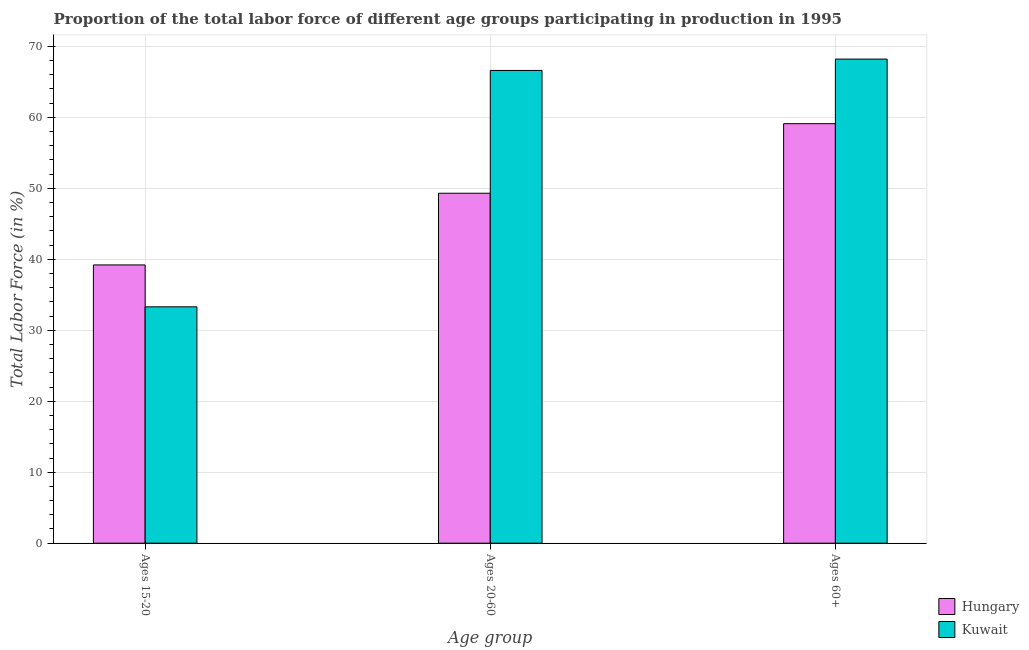How many different coloured bars are there?
Provide a short and direct response. 2. Are the number of bars per tick equal to the number of legend labels?
Ensure brevity in your answer.  Yes. How many bars are there on the 3rd tick from the left?
Ensure brevity in your answer.  2. What is the label of the 2nd group of bars from the left?
Ensure brevity in your answer.  Ages 20-60. What is the percentage of labor force within the age group 15-20 in Kuwait?
Keep it short and to the point. 33.3. Across all countries, what is the maximum percentage of labor force within the age group 20-60?
Make the answer very short. 66.6. Across all countries, what is the minimum percentage of labor force within the age group 15-20?
Provide a succinct answer. 33.3. In which country was the percentage of labor force within the age group 15-20 maximum?
Give a very brief answer. Hungary. In which country was the percentage of labor force within the age group 20-60 minimum?
Your response must be concise. Hungary. What is the total percentage of labor force above age 60 in the graph?
Ensure brevity in your answer.  127.3. What is the difference between the percentage of labor force within the age group 15-20 in Kuwait and that in Hungary?
Your answer should be compact. -5.9. What is the average percentage of labor force within the age group 20-60 per country?
Offer a terse response. 57.95. What is the difference between the percentage of labor force above age 60 and percentage of labor force within the age group 15-20 in Hungary?
Your response must be concise. 19.9. In how many countries, is the percentage of labor force above age 60 greater than 12 %?
Your response must be concise. 2. What is the ratio of the percentage of labor force within the age group 15-20 in Hungary to that in Kuwait?
Your answer should be very brief. 1.18. Is the percentage of labor force within the age group 15-20 in Kuwait less than that in Hungary?
Give a very brief answer. Yes. Is the difference between the percentage of labor force above age 60 in Hungary and Kuwait greater than the difference between the percentage of labor force within the age group 15-20 in Hungary and Kuwait?
Keep it short and to the point. No. What is the difference between the highest and the second highest percentage of labor force within the age group 20-60?
Provide a short and direct response. 17.3. What is the difference between the highest and the lowest percentage of labor force within the age group 20-60?
Provide a succinct answer. 17.3. In how many countries, is the percentage of labor force within the age group 15-20 greater than the average percentage of labor force within the age group 15-20 taken over all countries?
Ensure brevity in your answer.  1. Is the sum of the percentage of labor force within the age group 15-20 in Hungary and Kuwait greater than the maximum percentage of labor force above age 60 across all countries?
Ensure brevity in your answer.  Yes. What does the 2nd bar from the left in Ages 60+ represents?
Provide a short and direct response. Kuwait. What does the 2nd bar from the right in Ages 15-20 represents?
Make the answer very short. Hungary. Is it the case that in every country, the sum of the percentage of labor force within the age group 15-20 and percentage of labor force within the age group 20-60 is greater than the percentage of labor force above age 60?
Your response must be concise. Yes. Are all the bars in the graph horizontal?
Your answer should be compact. No. How many countries are there in the graph?
Ensure brevity in your answer.  2. What is the difference between two consecutive major ticks on the Y-axis?
Ensure brevity in your answer.  10. Does the graph contain any zero values?
Your answer should be compact. No. Does the graph contain grids?
Provide a short and direct response. Yes. What is the title of the graph?
Offer a very short reply. Proportion of the total labor force of different age groups participating in production in 1995. Does "Pakistan" appear as one of the legend labels in the graph?
Keep it short and to the point. No. What is the label or title of the X-axis?
Offer a very short reply. Age group. What is the Total Labor Force (in %) in Hungary in Ages 15-20?
Provide a short and direct response. 39.2. What is the Total Labor Force (in %) in Kuwait in Ages 15-20?
Provide a short and direct response. 33.3. What is the Total Labor Force (in %) of Hungary in Ages 20-60?
Offer a very short reply. 49.3. What is the Total Labor Force (in %) of Kuwait in Ages 20-60?
Offer a terse response. 66.6. What is the Total Labor Force (in %) in Hungary in Ages 60+?
Offer a very short reply. 59.1. What is the Total Labor Force (in %) of Kuwait in Ages 60+?
Give a very brief answer. 68.2. Across all Age group, what is the maximum Total Labor Force (in %) of Hungary?
Ensure brevity in your answer.  59.1. Across all Age group, what is the maximum Total Labor Force (in %) of Kuwait?
Give a very brief answer. 68.2. Across all Age group, what is the minimum Total Labor Force (in %) of Hungary?
Offer a very short reply. 39.2. Across all Age group, what is the minimum Total Labor Force (in %) in Kuwait?
Provide a short and direct response. 33.3. What is the total Total Labor Force (in %) of Hungary in the graph?
Offer a terse response. 147.6. What is the total Total Labor Force (in %) in Kuwait in the graph?
Offer a very short reply. 168.1. What is the difference between the Total Labor Force (in %) of Hungary in Ages 15-20 and that in Ages 20-60?
Provide a succinct answer. -10.1. What is the difference between the Total Labor Force (in %) in Kuwait in Ages 15-20 and that in Ages 20-60?
Your answer should be compact. -33.3. What is the difference between the Total Labor Force (in %) in Hungary in Ages 15-20 and that in Ages 60+?
Offer a very short reply. -19.9. What is the difference between the Total Labor Force (in %) of Kuwait in Ages 15-20 and that in Ages 60+?
Provide a short and direct response. -34.9. What is the difference between the Total Labor Force (in %) in Kuwait in Ages 20-60 and that in Ages 60+?
Give a very brief answer. -1.6. What is the difference between the Total Labor Force (in %) in Hungary in Ages 15-20 and the Total Labor Force (in %) in Kuwait in Ages 20-60?
Your response must be concise. -27.4. What is the difference between the Total Labor Force (in %) in Hungary in Ages 15-20 and the Total Labor Force (in %) in Kuwait in Ages 60+?
Your response must be concise. -29. What is the difference between the Total Labor Force (in %) in Hungary in Ages 20-60 and the Total Labor Force (in %) in Kuwait in Ages 60+?
Ensure brevity in your answer.  -18.9. What is the average Total Labor Force (in %) of Hungary per Age group?
Provide a short and direct response. 49.2. What is the average Total Labor Force (in %) of Kuwait per Age group?
Offer a very short reply. 56.03. What is the difference between the Total Labor Force (in %) of Hungary and Total Labor Force (in %) of Kuwait in Ages 15-20?
Your answer should be very brief. 5.9. What is the difference between the Total Labor Force (in %) of Hungary and Total Labor Force (in %) of Kuwait in Ages 20-60?
Your answer should be very brief. -17.3. What is the difference between the Total Labor Force (in %) in Hungary and Total Labor Force (in %) in Kuwait in Ages 60+?
Provide a succinct answer. -9.1. What is the ratio of the Total Labor Force (in %) in Hungary in Ages 15-20 to that in Ages 20-60?
Give a very brief answer. 0.8. What is the ratio of the Total Labor Force (in %) of Kuwait in Ages 15-20 to that in Ages 20-60?
Offer a terse response. 0.5. What is the ratio of the Total Labor Force (in %) in Hungary in Ages 15-20 to that in Ages 60+?
Your response must be concise. 0.66. What is the ratio of the Total Labor Force (in %) of Kuwait in Ages 15-20 to that in Ages 60+?
Your answer should be compact. 0.49. What is the ratio of the Total Labor Force (in %) of Hungary in Ages 20-60 to that in Ages 60+?
Provide a succinct answer. 0.83. What is the ratio of the Total Labor Force (in %) in Kuwait in Ages 20-60 to that in Ages 60+?
Keep it short and to the point. 0.98. What is the difference between the highest and the second highest Total Labor Force (in %) in Hungary?
Provide a succinct answer. 9.8. What is the difference between the highest and the lowest Total Labor Force (in %) in Kuwait?
Offer a terse response. 34.9. 